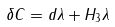<formula> <loc_0><loc_0><loc_500><loc_500>\delta C = d \lambda + H _ { 3 } \lambda</formula> 